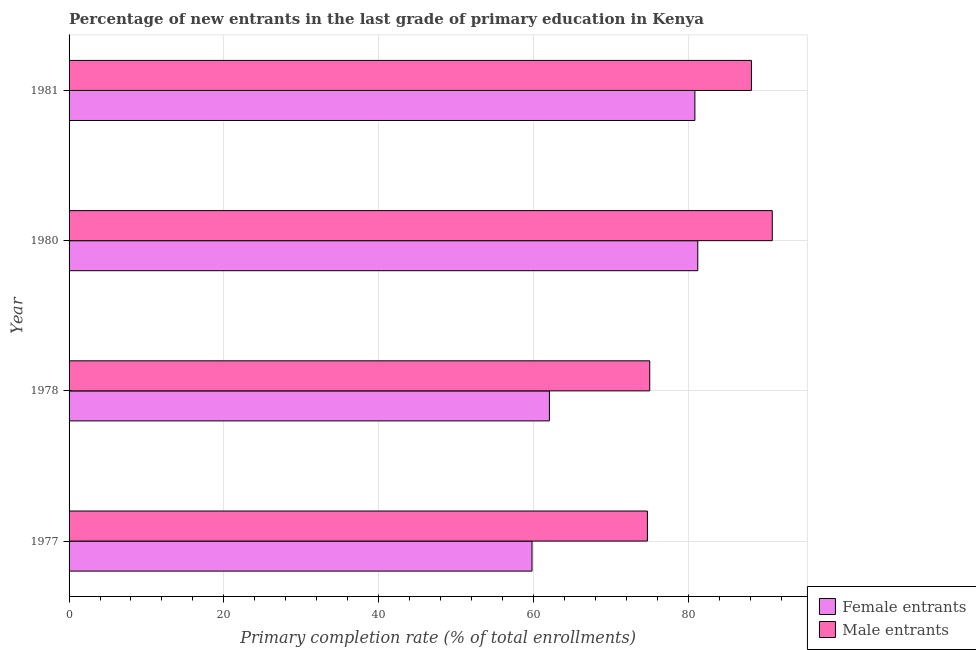How many different coloured bars are there?
Offer a very short reply. 2. How many groups of bars are there?
Provide a succinct answer. 4. How many bars are there on the 1st tick from the top?
Provide a short and direct response. 2. In how many cases, is the number of bars for a given year not equal to the number of legend labels?
Keep it short and to the point. 0. What is the primary completion rate of female entrants in 1977?
Ensure brevity in your answer.  59.82. Across all years, what is the maximum primary completion rate of female entrants?
Keep it short and to the point. 81.25. Across all years, what is the minimum primary completion rate of male entrants?
Your response must be concise. 74.74. In which year was the primary completion rate of female entrants maximum?
Give a very brief answer. 1980. What is the total primary completion rate of female entrants in the graph?
Give a very brief answer. 284.01. What is the difference between the primary completion rate of female entrants in 1977 and that in 1981?
Your answer should be compact. -21.05. What is the difference between the primary completion rate of female entrants in 1981 and the primary completion rate of male entrants in 1977?
Keep it short and to the point. 6.14. What is the average primary completion rate of female entrants per year?
Make the answer very short. 71. In the year 1978, what is the difference between the primary completion rate of female entrants and primary completion rate of male entrants?
Ensure brevity in your answer.  -12.97. What is the ratio of the primary completion rate of female entrants in 1978 to that in 1981?
Provide a succinct answer. 0.77. What is the difference between the highest and the second highest primary completion rate of male entrants?
Your response must be concise. 2.69. What is the difference between the highest and the lowest primary completion rate of female entrants?
Offer a terse response. 21.42. In how many years, is the primary completion rate of female entrants greater than the average primary completion rate of female entrants taken over all years?
Offer a very short reply. 2. What does the 2nd bar from the top in 1980 represents?
Give a very brief answer. Female entrants. What does the 1st bar from the bottom in 1980 represents?
Keep it short and to the point. Female entrants. Are all the bars in the graph horizontal?
Make the answer very short. Yes. What is the difference between two consecutive major ticks on the X-axis?
Your answer should be compact. 20. Are the values on the major ticks of X-axis written in scientific E-notation?
Give a very brief answer. No. Does the graph contain any zero values?
Make the answer very short. No. Does the graph contain grids?
Provide a succinct answer. Yes. How are the legend labels stacked?
Offer a terse response. Vertical. What is the title of the graph?
Make the answer very short. Percentage of new entrants in the last grade of primary education in Kenya. What is the label or title of the X-axis?
Make the answer very short. Primary completion rate (% of total enrollments). What is the Primary completion rate (% of total enrollments) of Female entrants in 1977?
Offer a terse response. 59.82. What is the Primary completion rate (% of total enrollments) of Male entrants in 1977?
Ensure brevity in your answer.  74.74. What is the Primary completion rate (% of total enrollments) in Female entrants in 1978?
Give a very brief answer. 62.07. What is the Primary completion rate (% of total enrollments) in Male entrants in 1978?
Ensure brevity in your answer.  75.04. What is the Primary completion rate (% of total enrollments) in Female entrants in 1980?
Provide a short and direct response. 81.25. What is the Primary completion rate (% of total enrollments) of Male entrants in 1980?
Your answer should be compact. 90.87. What is the Primary completion rate (% of total enrollments) in Female entrants in 1981?
Your answer should be compact. 80.87. What is the Primary completion rate (% of total enrollments) in Male entrants in 1981?
Keep it short and to the point. 88.18. Across all years, what is the maximum Primary completion rate (% of total enrollments) of Female entrants?
Provide a succinct answer. 81.25. Across all years, what is the maximum Primary completion rate (% of total enrollments) in Male entrants?
Provide a short and direct response. 90.87. Across all years, what is the minimum Primary completion rate (% of total enrollments) of Female entrants?
Your response must be concise. 59.82. Across all years, what is the minimum Primary completion rate (% of total enrollments) in Male entrants?
Your answer should be very brief. 74.74. What is the total Primary completion rate (% of total enrollments) in Female entrants in the graph?
Keep it short and to the point. 284.01. What is the total Primary completion rate (% of total enrollments) of Male entrants in the graph?
Offer a very short reply. 328.82. What is the difference between the Primary completion rate (% of total enrollments) in Female entrants in 1977 and that in 1978?
Offer a terse response. -2.25. What is the difference between the Primary completion rate (% of total enrollments) of Male entrants in 1977 and that in 1978?
Your answer should be compact. -0.3. What is the difference between the Primary completion rate (% of total enrollments) in Female entrants in 1977 and that in 1980?
Provide a succinct answer. -21.42. What is the difference between the Primary completion rate (% of total enrollments) in Male entrants in 1977 and that in 1980?
Offer a terse response. -16.14. What is the difference between the Primary completion rate (% of total enrollments) in Female entrants in 1977 and that in 1981?
Make the answer very short. -21.05. What is the difference between the Primary completion rate (% of total enrollments) in Male entrants in 1977 and that in 1981?
Provide a short and direct response. -13.44. What is the difference between the Primary completion rate (% of total enrollments) of Female entrants in 1978 and that in 1980?
Give a very brief answer. -19.17. What is the difference between the Primary completion rate (% of total enrollments) in Male entrants in 1978 and that in 1980?
Provide a succinct answer. -15.83. What is the difference between the Primary completion rate (% of total enrollments) of Female entrants in 1978 and that in 1981?
Give a very brief answer. -18.8. What is the difference between the Primary completion rate (% of total enrollments) of Male entrants in 1978 and that in 1981?
Offer a terse response. -13.14. What is the difference between the Primary completion rate (% of total enrollments) in Female entrants in 1980 and that in 1981?
Your response must be concise. 0.37. What is the difference between the Primary completion rate (% of total enrollments) of Male entrants in 1980 and that in 1981?
Make the answer very short. 2.69. What is the difference between the Primary completion rate (% of total enrollments) of Female entrants in 1977 and the Primary completion rate (% of total enrollments) of Male entrants in 1978?
Keep it short and to the point. -15.21. What is the difference between the Primary completion rate (% of total enrollments) in Female entrants in 1977 and the Primary completion rate (% of total enrollments) in Male entrants in 1980?
Make the answer very short. -31.05. What is the difference between the Primary completion rate (% of total enrollments) in Female entrants in 1977 and the Primary completion rate (% of total enrollments) in Male entrants in 1981?
Ensure brevity in your answer.  -28.36. What is the difference between the Primary completion rate (% of total enrollments) of Female entrants in 1978 and the Primary completion rate (% of total enrollments) of Male entrants in 1980?
Your answer should be very brief. -28.8. What is the difference between the Primary completion rate (% of total enrollments) in Female entrants in 1978 and the Primary completion rate (% of total enrollments) in Male entrants in 1981?
Offer a very short reply. -26.11. What is the difference between the Primary completion rate (% of total enrollments) of Female entrants in 1980 and the Primary completion rate (% of total enrollments) of Male entrants in 1981?
Make the answer very short. -6.93. What is the average Primary completion rate (% of total enrollments) of Female entrants per year?
Give a very brief answer. 71. What is the average Primary completion rate (% of total enrollments) in Male entrants per year?
Keep it short and to the point. 82.21. In the year 1977, what is the difference between the Primary completion rate (% of total enrollments) of Female entrants and Primary completion rate (% of total enrollments) of Male entrants?
Your response must be concise. -14.91. In the year 1978, what is the difference between the Primary completion rate (% of total enrollments) of Female entrants and Primary completion rate (% of total enrollments) of Male entrants?
Offer a very short reply. -12.97. In the year 1980, what is the difference between the Primary completion rate (% of total enrollments) in Female entrants and Primary completion rate (% of total enrollments) in Male entrants?
Your answer should be compact. -9.63. In the year 1981, what is the difference between the Primary completion rate (% of total enrollments) in Female entrants and Primary completion rate (% of total enrollments) in Male entrants?
Offer a terse response. -7.31. What is the ratio of the Primary completion rate (% of total enrollments) in Female entrants in 1977 to that in 1978?
Make the answer very short. 0.96. What is the ratio of the Primary completion rate (% of total enrollments) in Male entrants in 1977 to that in 1978?
Offer a very short reply. 1. What is the ratio of the Primary completion rate (% of total enrollments) of Female entrants in 1977 to that in 1980?
Your answer should be compact. 0.74. What is the ratio of the Primary completion rate (% of total enrollments) in Male entrants in 1977 to that in 1980?
Provide a short and direct response. 0.82. What is the ratio of the Primary completion rate (% of total enrollments) of Female entrants in 1977 to that in 1981?
Your answer should be very brief. 0.74. What is the ratio of the Primary completion rate (% of total enrollments) of Male entrants in 1977 to that in 1981?
Offer a terse response. 0.85. What is the ratio of the Primary completion rate (% of total enrollments) in Female entrants in 1978 to that in 1980?
Provide a short and direct response. 0.76. What is the ratio of the Primary completion rate (% of total enrollments) of Male entrants in 1978 to that in 1980?
Provide a short and direct response. 0.83. What is the ratio of the Primary completion rate (% of total enrollments) in Female entrants in 1978 to that in 1981?
Ensure brevity in your answer.  0.77. What is the ratio of the Primary completion rate (% of total enrollments) of Male entrants in 1978 to that in 1981?
Your answer should be very brief. 0.85. What is the ratio of the Primary completion rate (% of total enrollments) of Female entrants in 1980 to that in 1981?
Your answer should be very brief. 1. What is the ratio of the Primary completion rate (% of total enrollments) of Male entrants in 1980 to that in 1981?
Give a very brief answer. 1.03. What is the difference between the highest and the second highest Primary completion rate (% of total enrollments) in Female entrants?
Provide a short and direct response. 0.37. What is the difference between the highest and the second highest Primary completion rate (% of total enrollments) in Male entrants?
Provide a short and direct response. 2.69. What is the difference between the highest and the lowest Primary completion rate (% of total enrollments) in Female entrants?
Ensure brevity in your answer.  21.42. What is the difference between the highest and the lowest Primary completion rate (% of total enrollments) of Male entrants?
Provide a succinct answer. 16.14. 